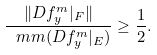<formula> <loc_0><loc_0><loc_500><loc_500>\frac { \| D f ^ { m } _ { y } | _ { F } \| } { \ m m ( D f ^ { m } _ { y } | _ { E } ) } \geq \frac { 1 } { 2 } .</formula> 